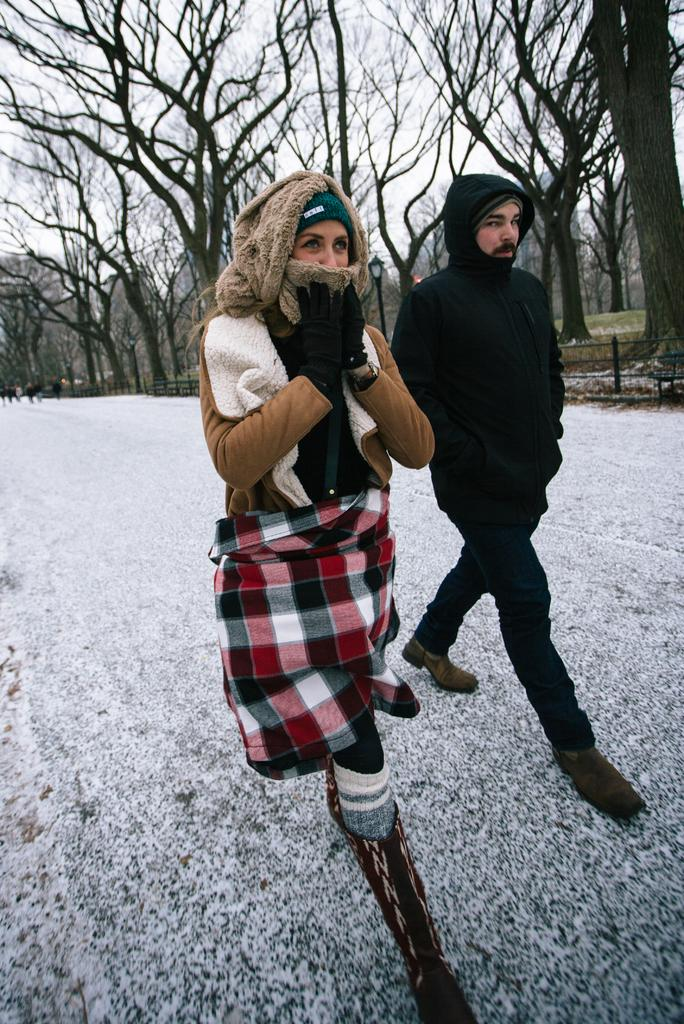Who can be seen in the image? There is a man and a woman in the image. What are the man and woman doing in the image? The man and woman are walking on a path in the image. What can be seen in the background of the image? There are trees and people visible in the background of the image. What architectural feature is present in the image? There is a fence in the image. What type of pies are being baked in the camp visible in the image? There is no camp or pies present in the image; it features a man and woman walking on a path with trees and a fence in the background. 